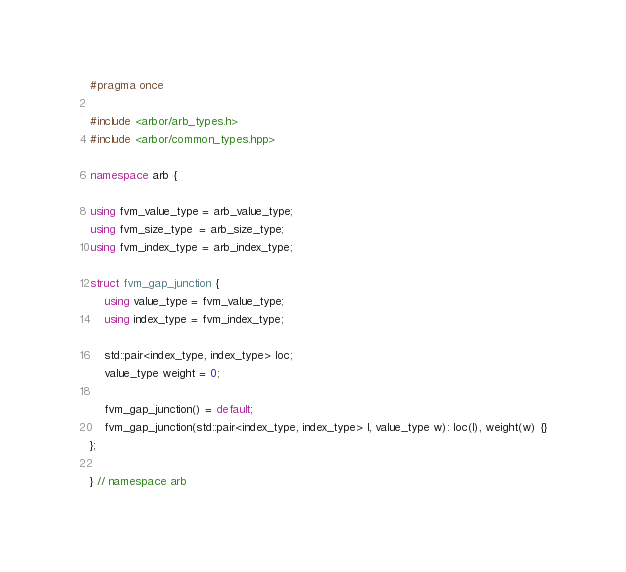<code> <loc_0><loc_0><loc_500><loc_500><_C++_>#pragma once

#include <arbor/arb_types.h>
#include <arbor/common_types.hpp>

namespace arb {

using fvm_value_type = arb_value_type;
using fvm_size_type  = arb_size_type;
using fvm_index_type = arb_index_type;

struct fvm_gap_junction {
    using value_type = fvm_value_type;
    using index_type = fvm_index_type;

    std::pair<index_type, index_type> loc;
    value_type weight = 0;

    fvm_gap_junction() = default;
    fvm_gap_junction(std::pair<index_type, index_type> l, value_type w): loc(l), weight(w) {}
};

} // namespace arb
</code> 